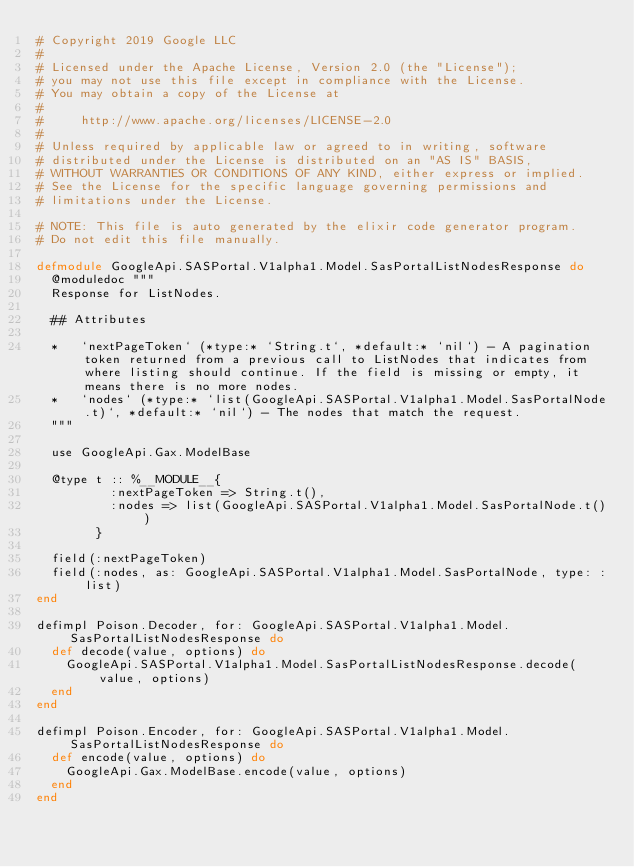Convert code to text. <code><loc_0><loc_0><loc_500><loc_500><_Elixir_># Copyright 2019 Google LLC
#
# Licensed under the Apache License, Version 2.0 (the "License");
# you may not use this file except in compliance with the License.
# You may obtain a copy of the License at
#
#     http://www.apache.org/licenses/LICENSE-2.0
#
# Unless required by applicable law or agreed to in writing, software
# distributed under the License is distributed on an "AS IS" BASIS,
# WITHOUT WARRANTIES OR CONDITIONS OF ANY KIND, either express or implied.
# See the License for the specific language governing permissions and
# limitations under the License.

# NOTE: This file is auto generated by the elixir code generator program.
# Do not edit this file manually.

defmodule GoogleApi.SASPortal.V1alpha1.Model.SasPortalListNodesResponse do
  @moduledoc """
  Response for ListNodes.

  ## Attributes

  *   `nextPageToken` (*type:* `String.t`, *default:* `nil`) - A pagination token returned from a previous call to ListNodes that indicates from where listing should continue. If the field is missing or empty, it means there is no more nodes.
  *   `nodes` (*type:* `list(GoogleApi.SASPortal.V1alpha1.Model.SasPortalNode.t)`, *default:* `nil`) - The nodes that match the request.
  """

  use GoogleApi.Gax.ModelBase

  @type t :: %__MODULE__{
          :nextPageToken => String.t(),
          :nodes => list(GoogleApi.SASPortal.V1alpha1.Model.SasPortalNode.t())
        }

  field(:nextPageToken)
  field(:nodes, as: GoogleApi.SASPortal.V1alpha1.Model.SasPortalNode, type: :list)
end

defimpl Poison.Decoder, for: GoogleApi.SASPortal.V1alpha1.Model.SasPortalListNodesResponse do
  def decode(value, options) do
    GoogleApi.SASPortal.V1alpha1.Model.SasPortalListNodesResponse.decode(value, options)
  end
end

defimpl Poison.Encoder, for: GoogleApi.SASPortal.V1alpha1.Model.SasPortalListNodesResponse do
  def encode(value, options) do
    GoogleApi.Gax.ModelBase.encode(value, options)
  end
end
</code> 